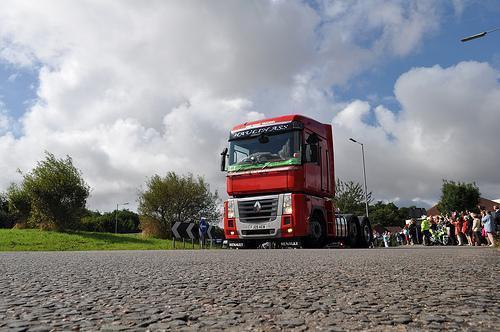How many trucks are in the photo?
Give a very brief answer. 1. 